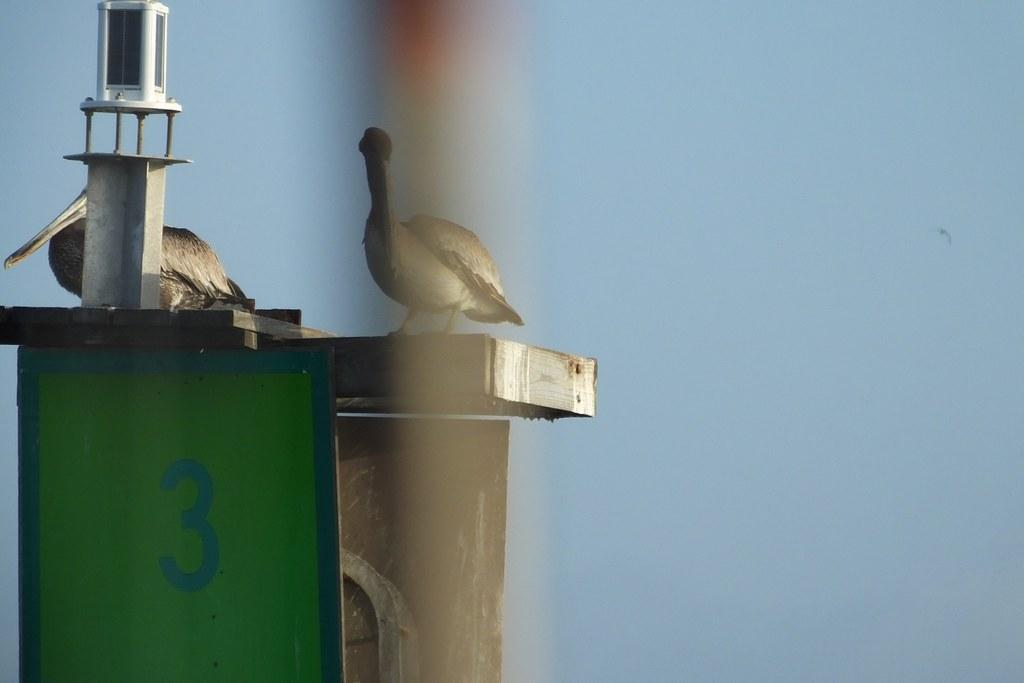How many birds can be seen in the image? There are two birds in the image. What is located on the surface in the image? There is an object on the surface in the image. Can you describe the board in the image? The board in the image has a number written on it. What can be seen in the background of the image? The sky is visible in the image. What type of grass is growing around the birds in the image? There is no grass visible in the image; it features two birds and other objects. 